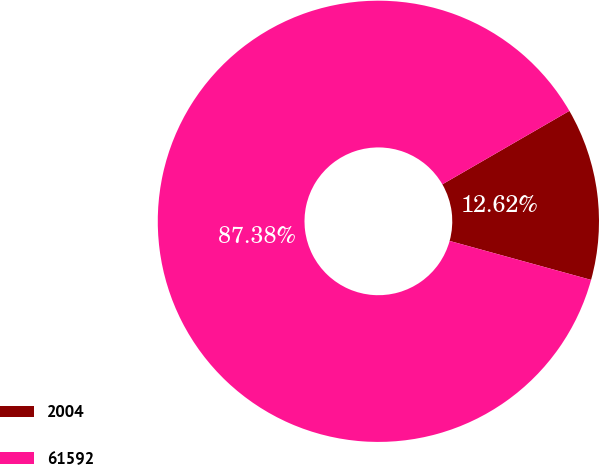Convert chart. <chart><loc_0><loc_0><loc_500><loc_500><pie_chart><fcel>2004<fcel>61592<nl><fcel>12.62%<fcel>87.38%<nl></chart> 